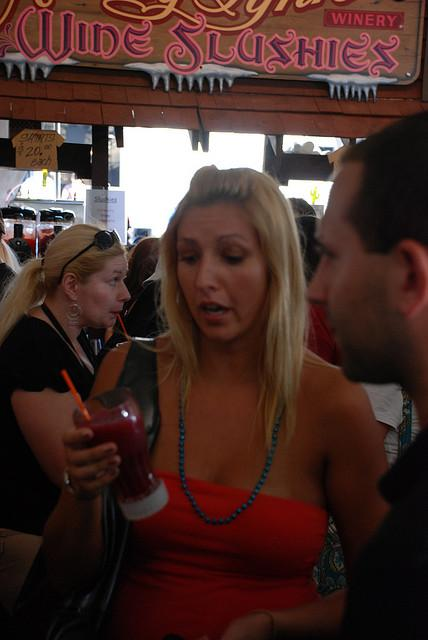Where are these people located? Please explain your reasoning. winery. People are crowded together in a place with signs about wine above. people are holding glasses. 